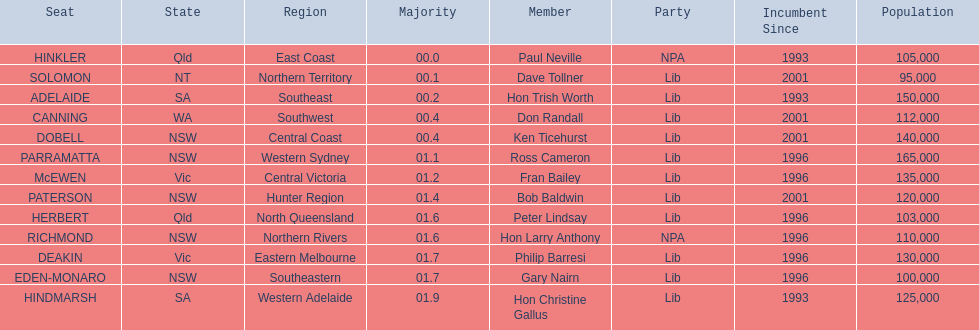Which seats are represented in the electoral system of australia? HINKLER, SOLOMON, ADELAIDE, CANNING, DOBELL, PARRAMATTA, McEWEN, PATERSON, HERBERT, RICHMOND, DEAKIN, EDEN-MONARO, HINDMARSH. What were their majority numbers of both hindmarsh and hinkler? HINKLER, HINDMARSH. Of those two seats, what is the difference in voting majority? 01.9. 